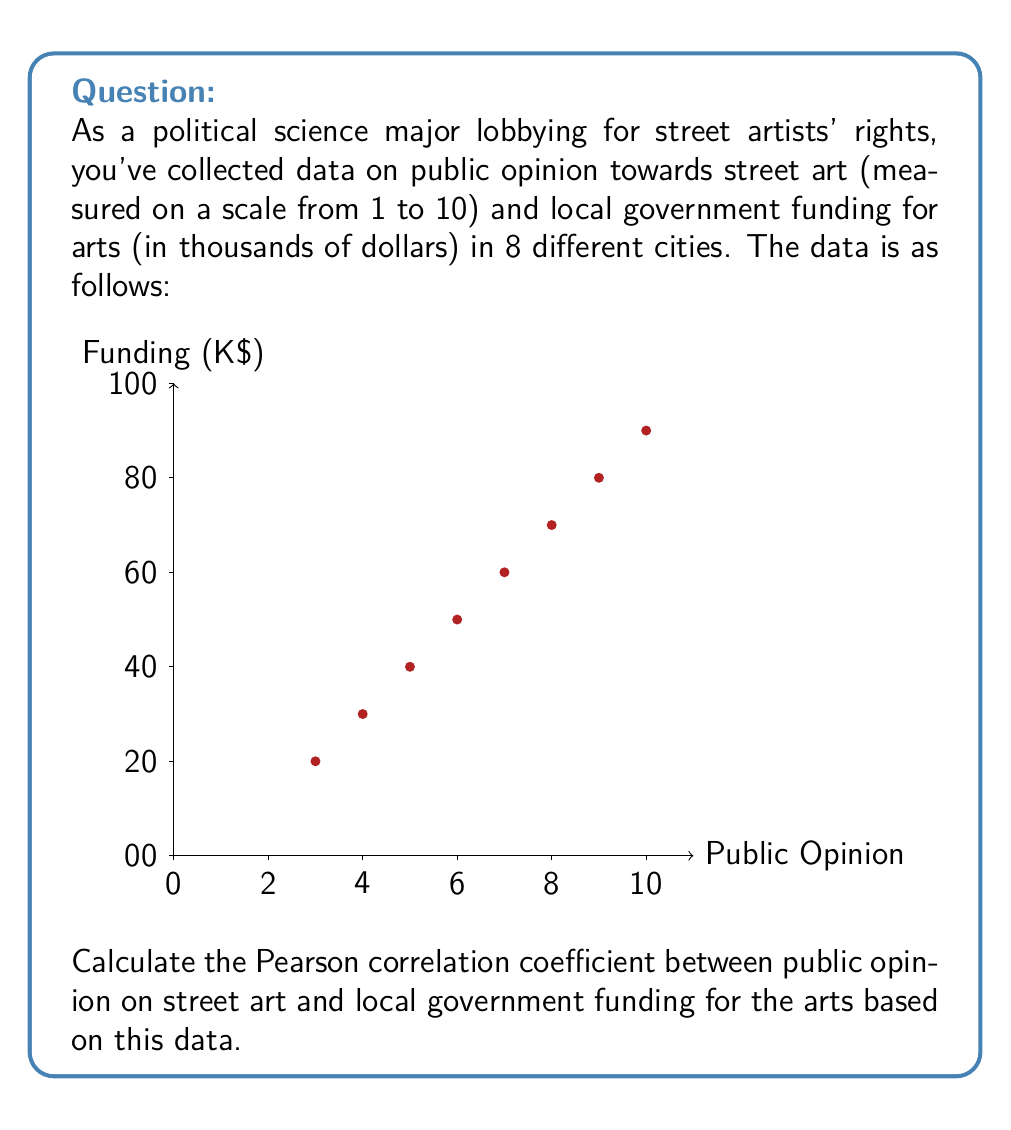Show me your answer to this math problem. To calculate the Pearson correlation coefficient, we'll use the formula:

$$ r = \frac{\sum_{i=1}^{n} (x_i - \bar{x})(y_i - \bar{y})}{\sqrt{\sum_{i=1}^{n} (x_i - \bar{x})^2 \sum_{i=1}^{n} (y_i - \bar{y})^2}} $$

Where:
$x_i$ = public opinion scores
$y_i$ = funding amounts
$\bar{x}$ = mean of public opinion scores
$\bar{y}$ = mean of funding amounts
$n$ = number of data points (8 in this case)

Step 1: Calculate means
$\bar{x} = \frac{3 + 4 + 5 + 6 + 7 + 8 + 9 + 10}{8} = 6.5$
$\bar{y} = \frac{10 + 15 + 20 + 25 + 30 + 35 + 40 + 45}{8} = 27.5$

Step 2: Calculate $(x_i - \bar{x})$, $(y_i - \bar{y})$, $(x_i - \bar{x})^2$, $(y_i - \bar{y})^2$, and $(x_i - \bar{x})(y_i - \bar{y})$ for each data point.

Step 3: Sum up the values from Step 2
$\sum (x_i - \bar{x})(y_i - \bar{y}) = 210$
$\sum (x_i - \bar{x})^2 = 42$
$\sum (y_i - \bar{y})^2 = 1050$

Step 4: Apply the formula
$$ r = \frac{210}{\sqrt{42 \times 1050}} = \frac{210}{\sqrt{44100}} = \frac{210}{210} = 1 $$

The Pearson correlation coefficient is 1, indicating a perfect positive linear correlation between public opinion on street art and local government funding for the arts.
Answer: $r = 1$ 